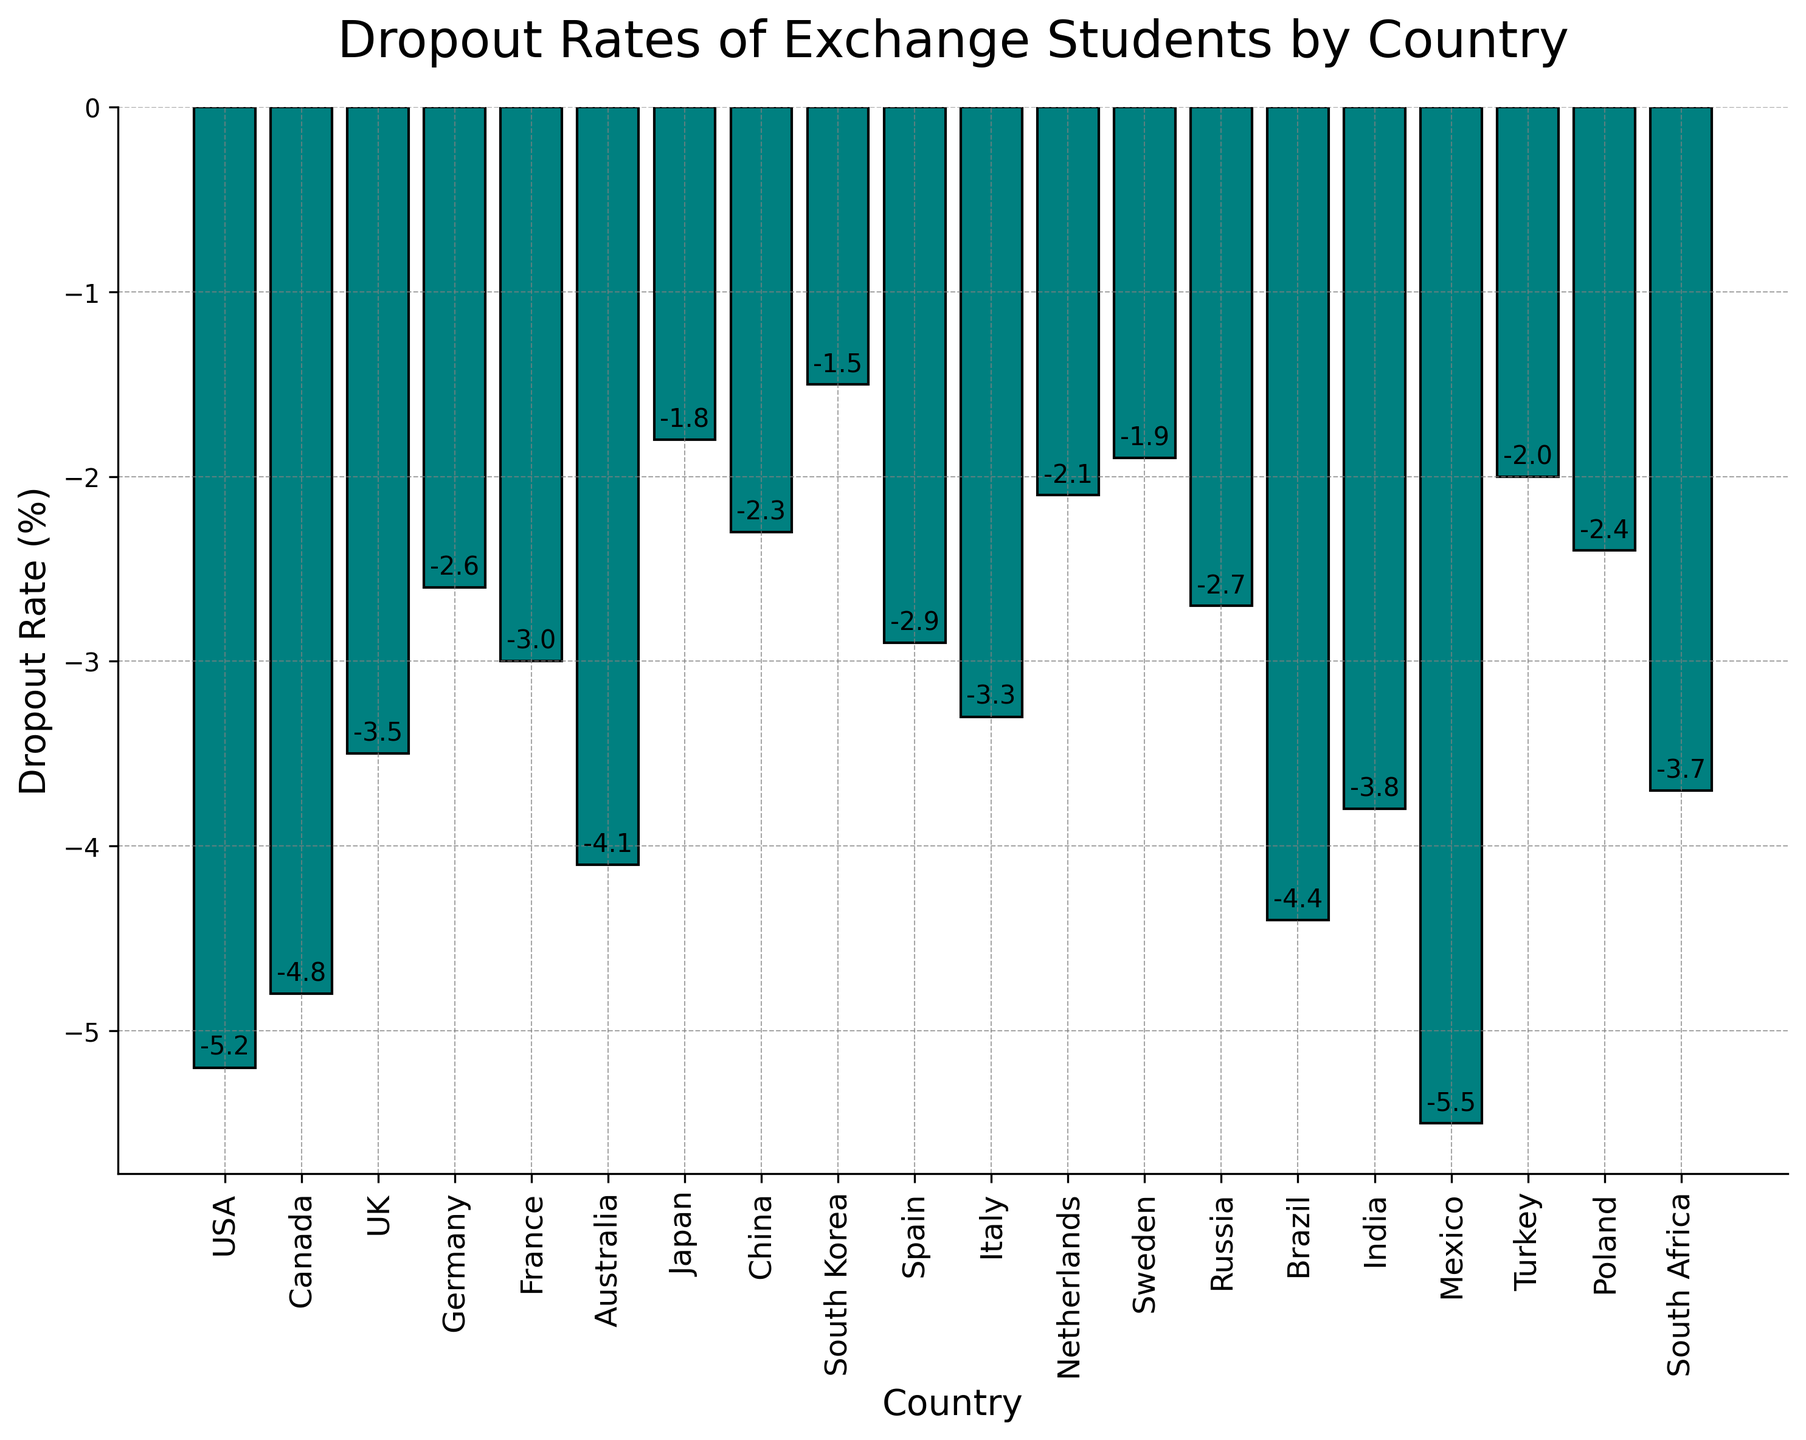What is the dropout rate for Mexico? The dropout rate for Mexico can be found by locating the bar labeled "Mexico" and identifying the value associated with it.
Answer: -5.5% Which country has the lowest dropout rate? Identify the bar with the highest (least negative) value. The bar for South Korea shows the least negative dropout rate.
Answer: South Korea Between the USA and Canada, which country has a higher dropout rate? Compare the heights of the bars for the USA and Canada. The USA has a higher (less negative) dropout rate than Canada.
Answer: USA What is the average dropout rate for the listed countries? Sum all dropout rates and divide by the number of countries. (-5.2 - 4.8 - 3.5 - 2.6 - 3.0 - 4.1 - 1.8 - 2.3 - 1.5 - 2.9 - 3.3 - 2.1 - 1.9 - 2.7 - 4.4 - 3.8 - 5.5 - 2.0 - 2.4 - 3.7) / 20 = -3.05
Answer: -3.05% Which country has a dropout rate closest to -3%? Locate the bar with a dropout rate value close to -3%. The bar for France shows a dropout rate of -3.0%.
Answer: France What is the difference in dropout rates between the country with the highest and lowest rates? Subtract the lowest dropout rate (South Korea) from the highest dropout rate (Mexico). -1.5 - (-5.5) = 4.0
Answer: 4.0 How many countries have a dropout rate higher (less negative) than -3%? Count the bars with dropout rates greater than (less negative) than -3%. USA, Canada, UK, Germany, Australia, Japan, China, South Korea, Netherlands, Sweden, Turkey, Poland. There are 12 such countries.
Answer: 12 Does any country have exactly the same dropout rate as Italy? Locate Italy's dropout rate, then check if any other country has the same dropout rate of -3.3%. No other countries match Italy's dropout rate exactly.
Answer: No Which country has a worse dropout rate than Spain but better than Brazil? Locate the dropout rates for Spain (-2.9%) and Brazil (-4.4%), then find countries with rates between these values. India (-3.8%) fits this criterion.
Answer: India What is the sum of dropout rates for France and China? Add the dropout rates of France and China. -3.0 + -2.3 = -5.3
Answer: -5.3 